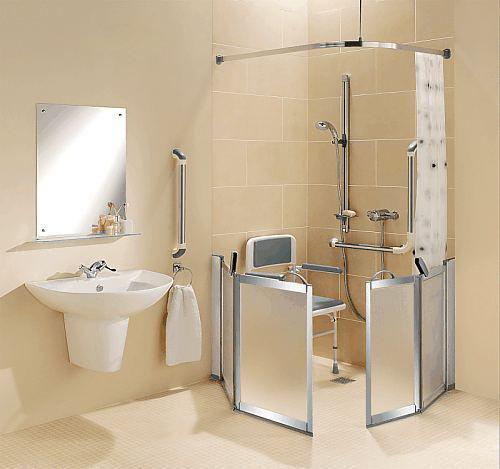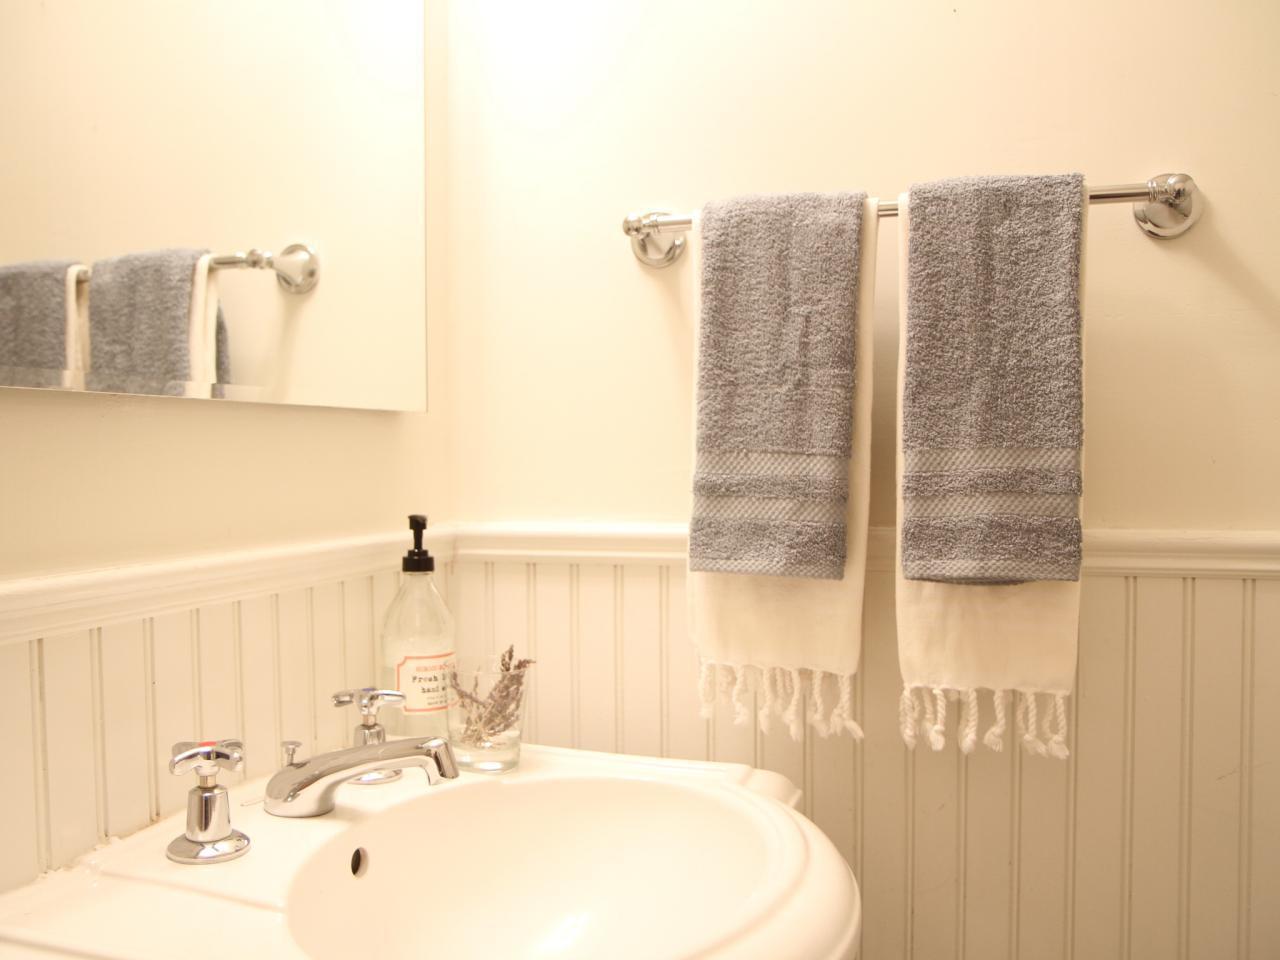The first image is the image on the left, the second image is the image on the right. Evaluate the accuracy of this statement regarding the images: "There are two sinks.". Is it true? Answer yes or no. Yes. The first image is the image on the left, the second image is the image on the right. For the images shown, is this caption "There is a toilet in one image and a shower in the other." true? Answer yes or no. No. 